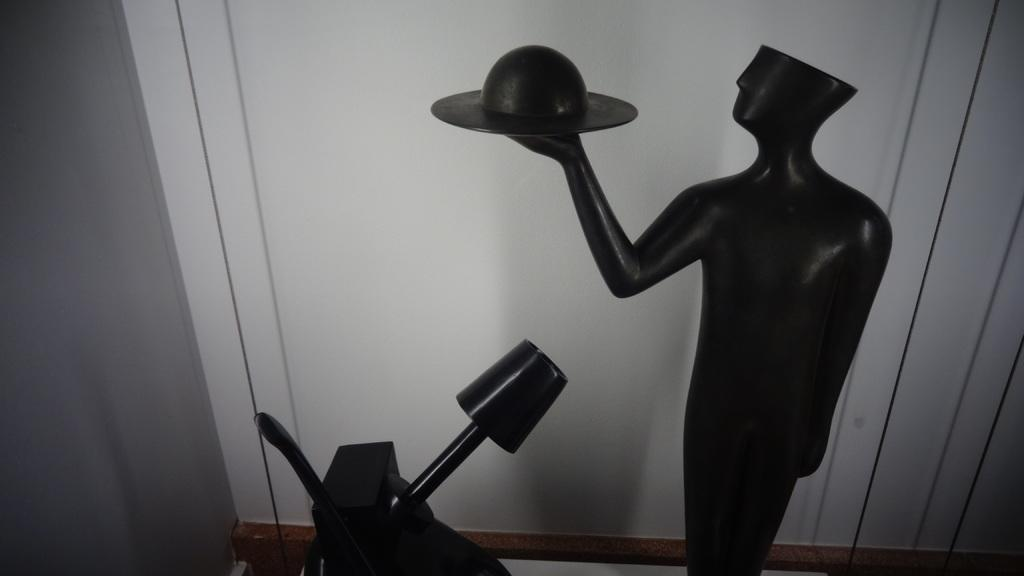What is the main subject in the image? There is a statue in the image. Can you describe the surroundings of the statue? There is a wall visible in the background of the image. What is the statue's tendency to interact with the lake in the image? There is no lake present in the image, so the statue's tendency to interact with a lake cannot be determined. 